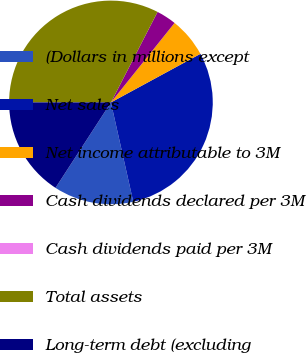Convert chart to OTSL. <chart><loc_0><loc_0><loc_500><loc_500><pie_chart><fcel>(Dollars in millions except<fcel>Net sales<fcel>Net income attributable to 3M<fcel>Cash dividends declared per 3M<fcel>Cash dividends paid per 3M<fcel>Total assets<fcel>Long-term debt (excluding<nl><fcel>12.68%<fcel>29.39%<fcel>6.34%<fcel>3.17%<fcel>0.0%<fcel>32.56%<fcel>15.85%<nl></chart> 